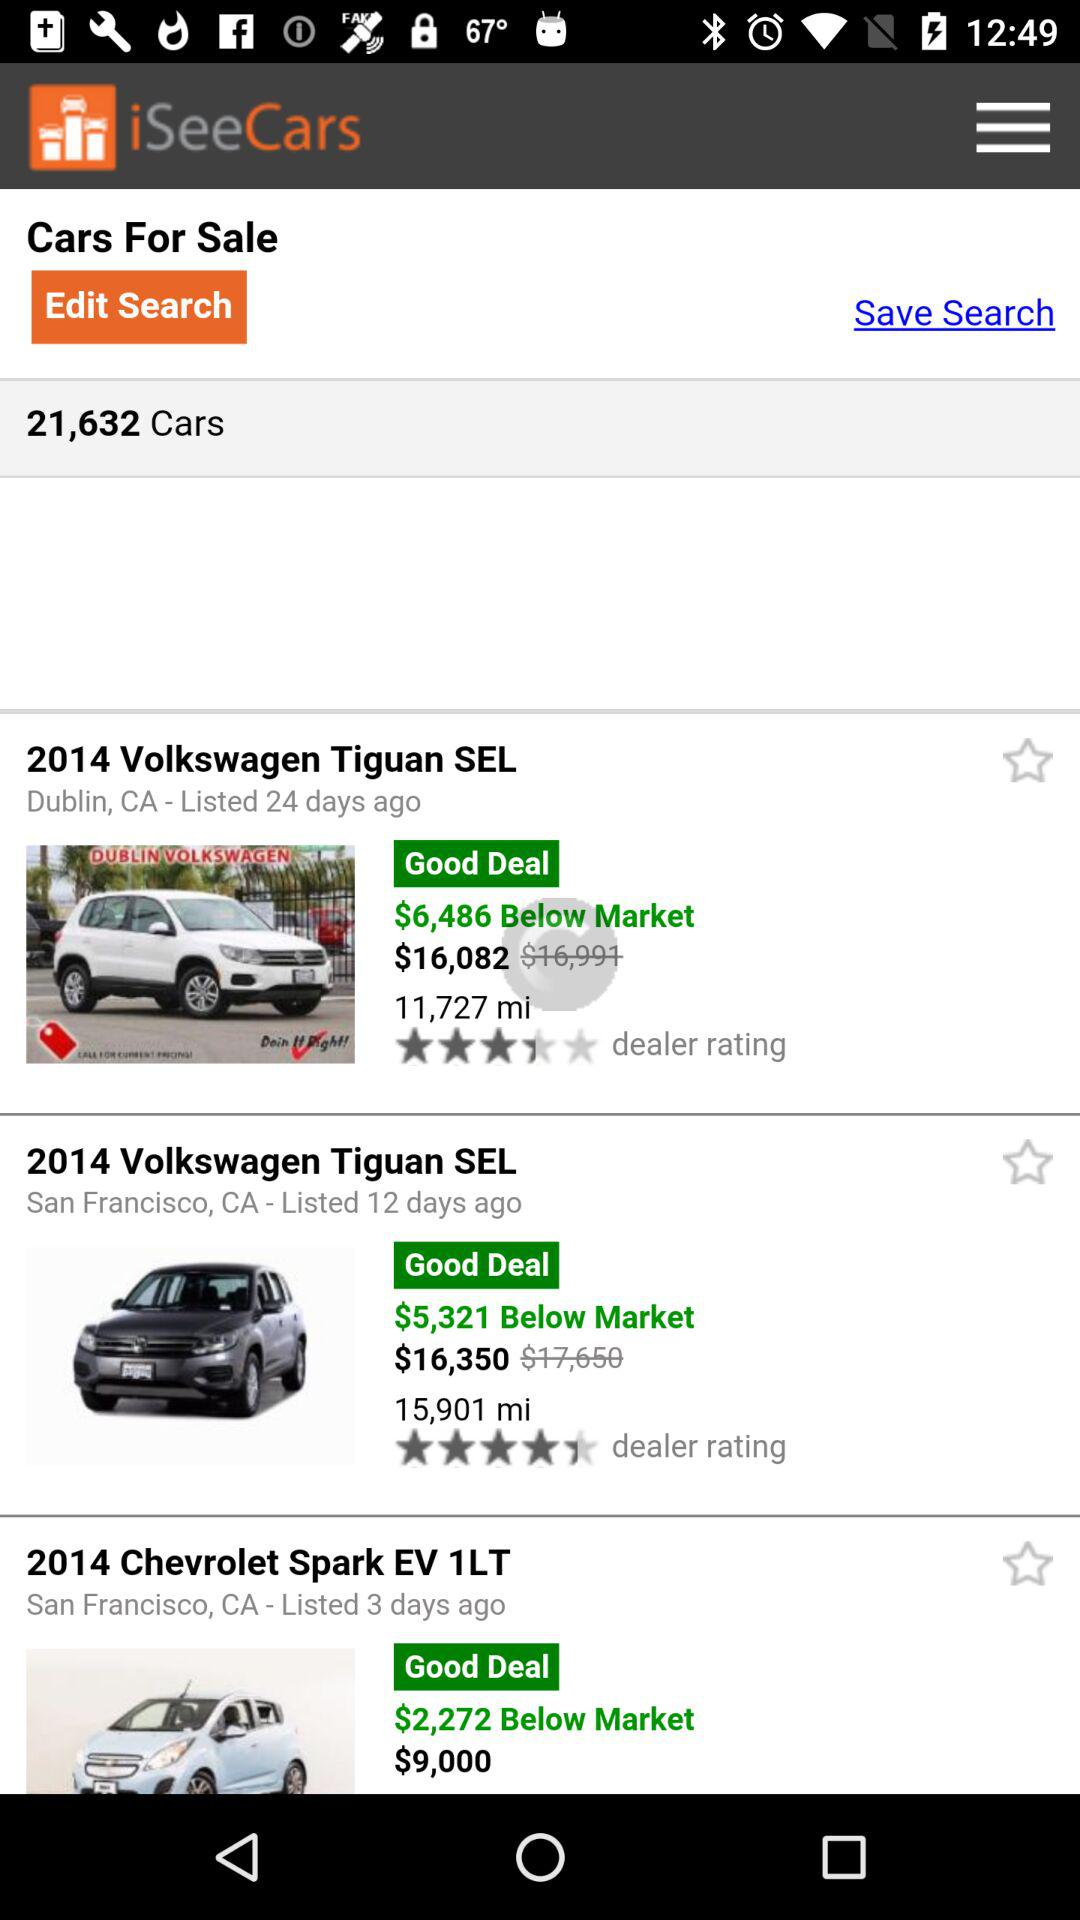What is the price of the 2014 Chevrolet Spark EV 1LT? The price of the 2014 Chevrolet Spark EV 1LT is $9,000. 